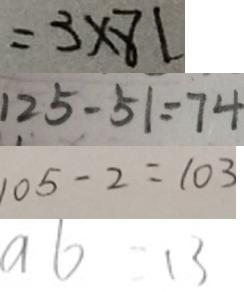Convert formula to latex. <formula><loc_0><loc_0><loc_500><loc_500>= 3 \times 8 1 
 1 2 5 - 5 1 = 7 4 
 1 0 5 - 2 = 1 0 3 
 a b - 1 3</formula> 